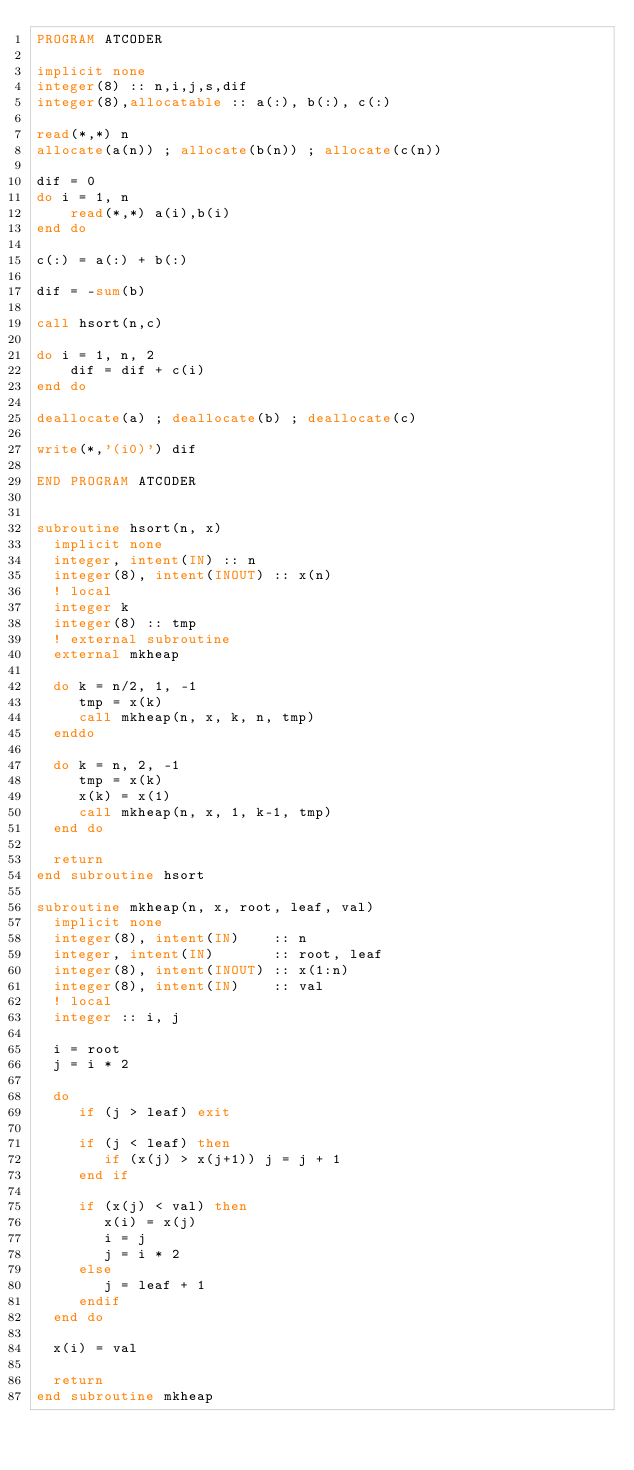<code> <loc_0><loc_0><loc_500><loc_500><_FORTRAN_>PROGRAM ATCODER

implicit none
integer(8) :: n,i,j,s,dif
integer(8),allocatable :: a(:), b(:), c(:)

read(*,*) n
allocate(a(n)) ; allocate(b(n)) ; allocate(c(n))

dif = 0
do i = 1, n
    read(*,*) a(i),b(i)
end do

c(:) = a(:) + b(:)

dif = -sum(b)

call hsort(n,c)

do i = 1, n, 2
    dif = dif + c(i)
end do

deallocate(a) ; deallocate(b) ; deallocate(c)

write(*,'(i0)') dif

END PROGRAM ATCODER


subroutine hsort(n, x)
  implicit none
  integer, intent(IN) :: n
  integer(8), intent(INOUT) :: x(n)
  ! local
  integer k
  integer(8) :: tmp
  ! external subroutine
  external mkheap
 
  do k = n/2, 1, -1
     tmp = x(k)
     call mkheap(n, x, k, n, tmp)
  enddo
 
  do k = n, 2, -1
     tmp = x(k)
     x(k) = x(1)
     call mkheap(n, x, 1, k-1, tmp)
  end do
 
  return
end subroutine hsort
 
subroutine mkheap(n, x, root, leaf, val)
  implicit none
  integer(8), intent(IN)    :: n
  integer, intent(IN)       :: root, leaf
  integer(8), intent(INOUT) :: x(1:n)
  integer(8), intent(IN)    :: val
  ! local
  integer :: i, j
 
  i = root
  j = i * 2
 
  do
     if (j > leaf) exit
 
     if (j < leaf) then
        if (x(j) > x(j+1)) j = j + 1
     end if
 
     if (x(j) < val) then
        x(i) = x(j)
        i = j
        j = i * 2
     else
        j = leaf + 1
     endif
  end do
 
  x(i) = val
 
  return
end subroutine mkheap</code> 